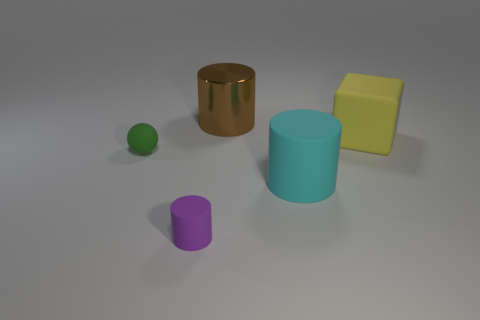Are there any other things that are the same material as the big brown cylinder?
Give a very brief answer. No. How many cylinders are either big gray rubber objects or green matte things?
Offer a terse response. 0. There is a tiny object that is to the left of the small rubber object that is in front of the big rubber cylinder; what color is it?
Provide a succinct answer. Green. There is a cyan cylinder that is made of the same material as the yellow cube; what is its size?
Offer a very short reply. Large. Is there a small green matte thing to the left of the large cylinder that is behind the small rubber thing that is behind the small rubber cylinder?
Provide a succinct answer. Yes. How many other cylinders are the same size as the cyan matte cylinder?
Ensure brevity in your answer.  1. Is the size of the matte object right of the cyan matte cylinder the same as the rubber thing that is on the left side of the small purple cylinder?
Provide a short and direct response. No. What is the shape of the object that is both behind the tiny purple cylinder and on the left side of the large brown shiny cylinder?
Make the answer very short. Sphere. Is there a green metallic cylinder?
Ensure brevity in your answer.  No. There is a small thing that is to the left of the small purple rubber object; what color is it?
Your answer should be compact. Green. 